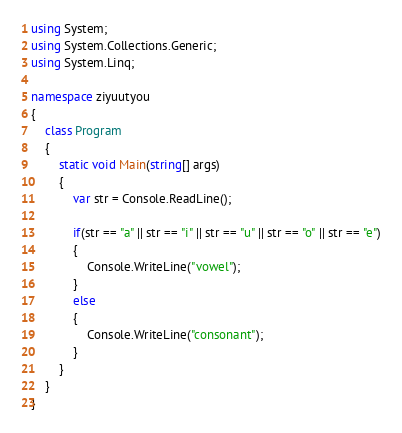Convert code to text. <code><loc_0><loc_0><loc_500><loc_500><_C#_>using System;
using System.Collections.Generic;
using System.Linq;

namespace ziyuutyou
{
    class Program
    {
        static void Main(string[] args)
        {
            var str = Console.ReadLine();

            if(str == "a" || str == "i" || str == "u" || str == "o" || str == "e")
            {
                Console.WriteLine("vowel");
            }
            else
            {
                Console.WriteLine("consonant");
            }
        }
    }
}
</code> 